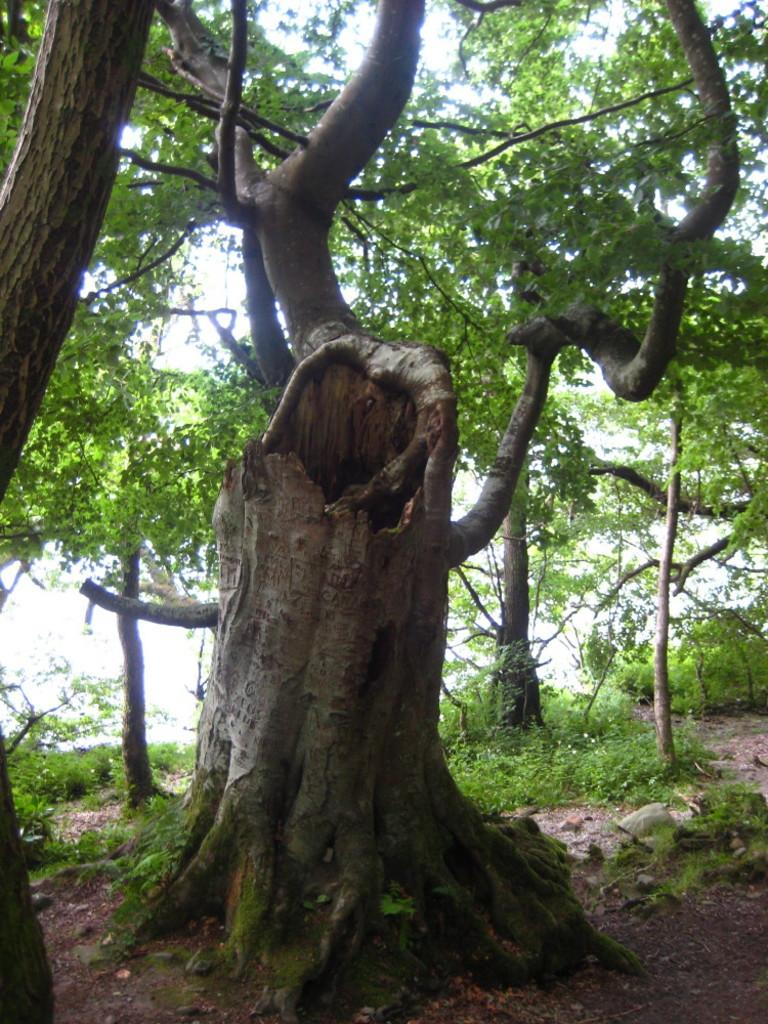What type of vegetation can be seen in the image? There are trees in the image. What else can be seen on the ground in the image? There are plants on the ground in the image. How much money is hidden in the trees in the image? There is no money present in the image; it only features trees and plants on the ground. 